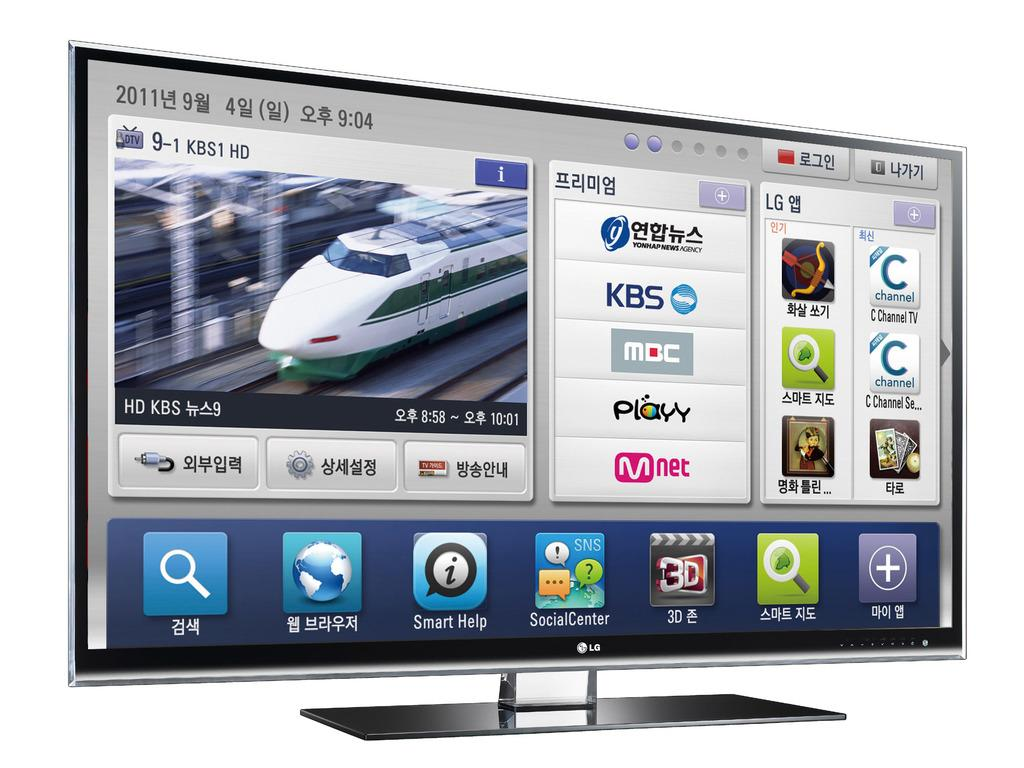<image>
Create a compact narrative representing the image presented. The screen for an LG branded Television that is displaying a train on it. 